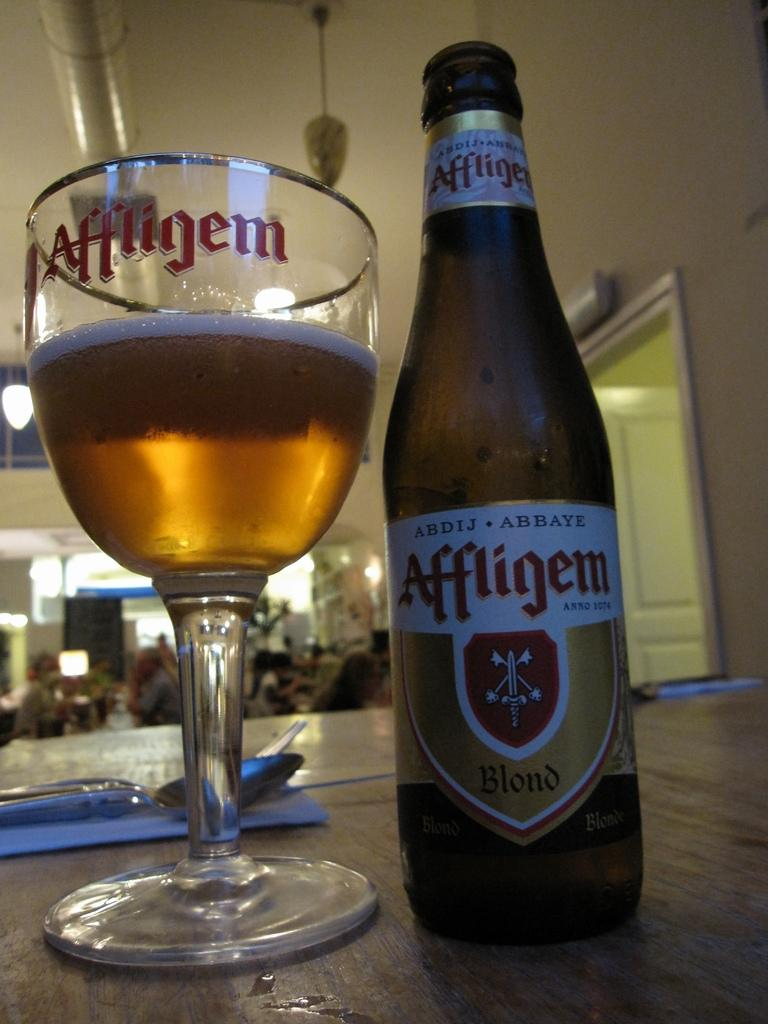<image>
Render a clear and concise summary of the photo. An Affligem bottle is next to a glass with the same logo. 